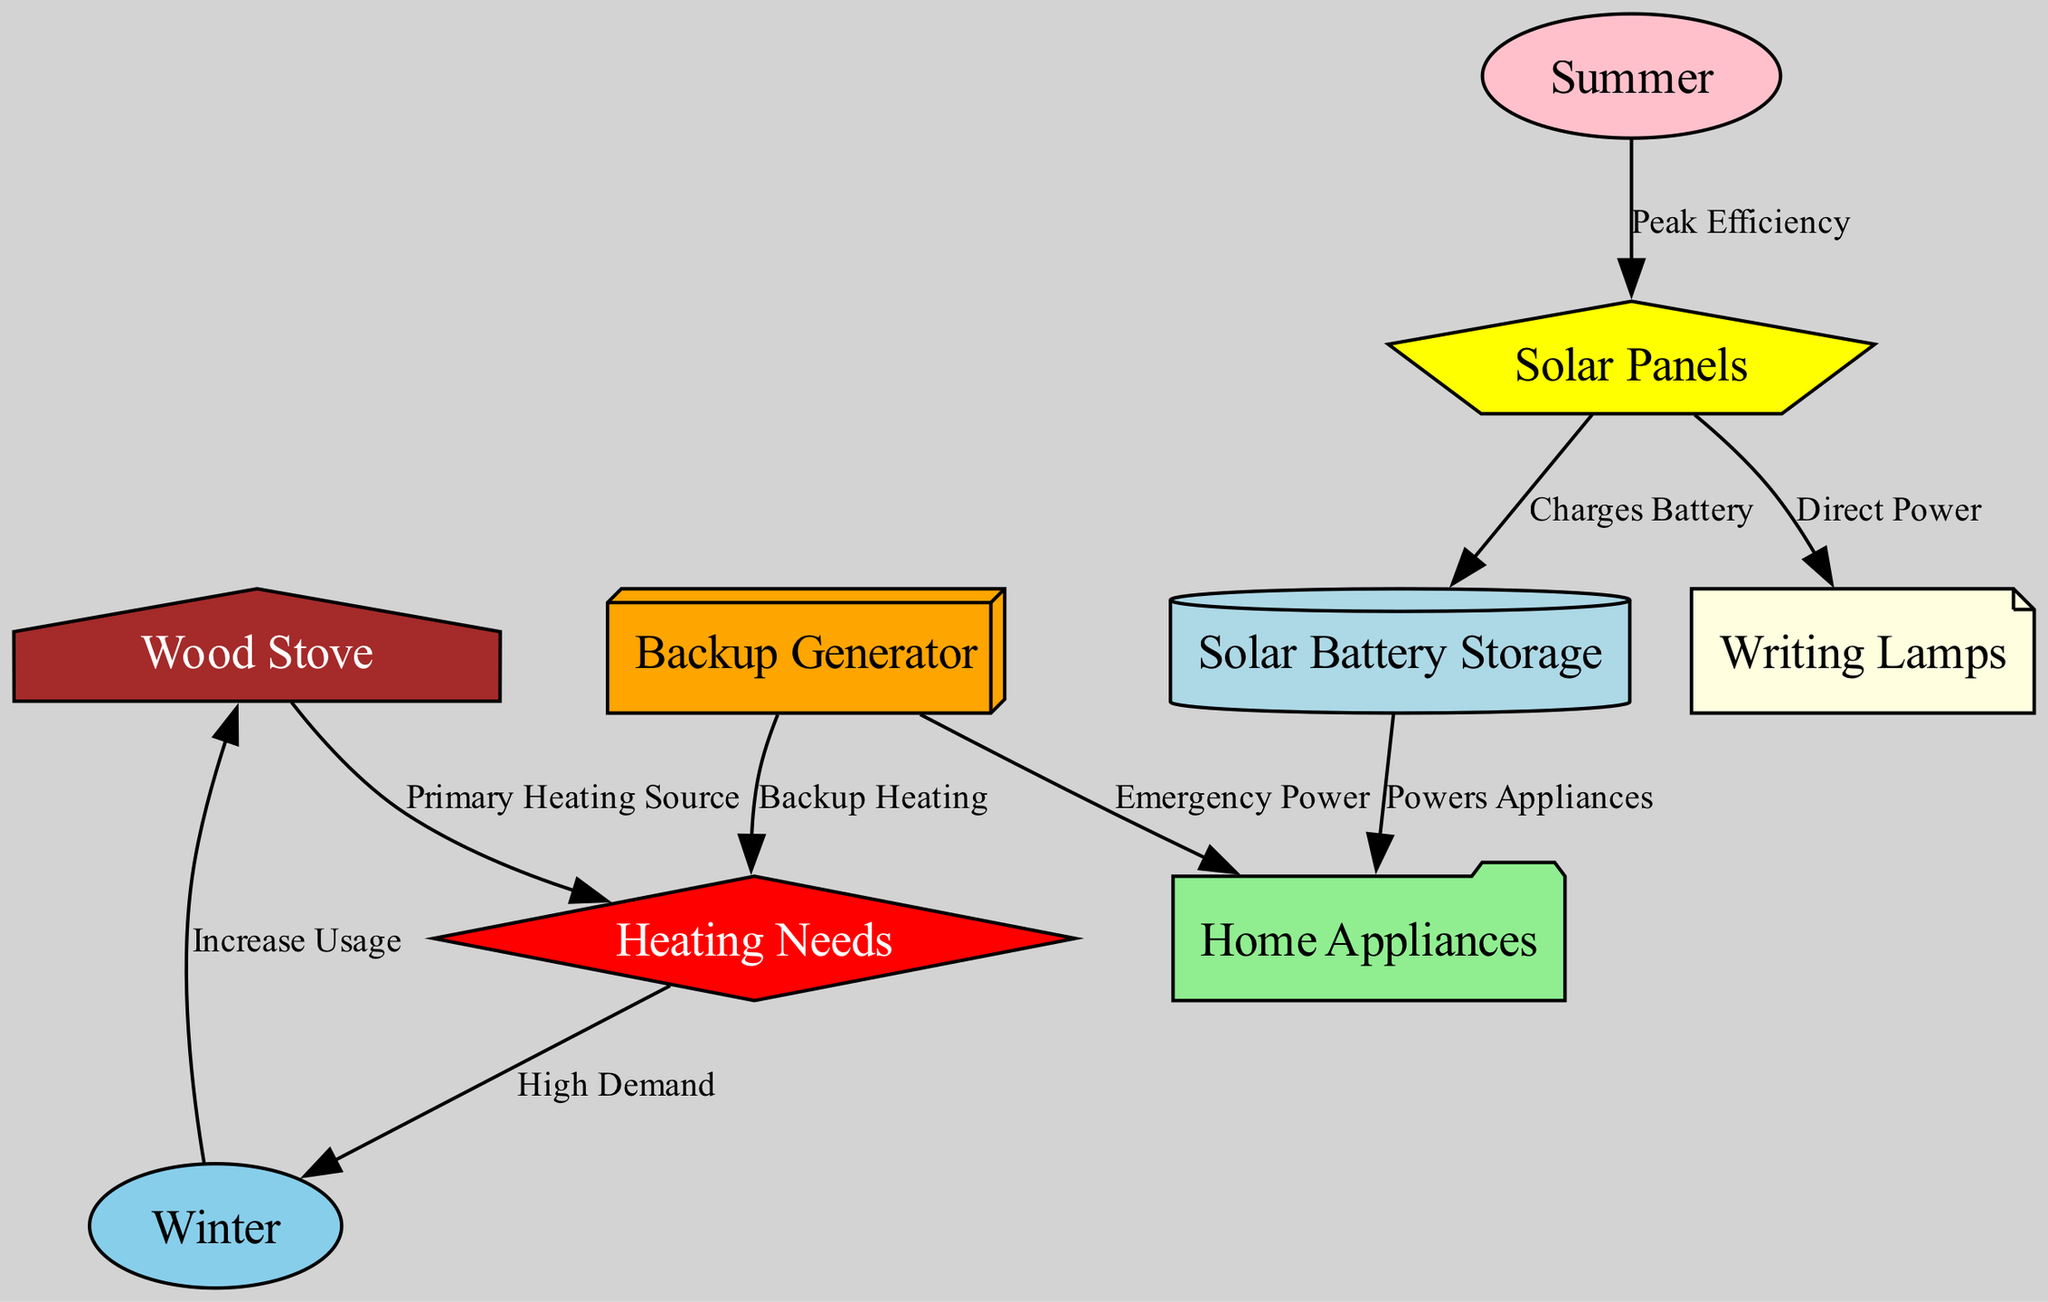What is the primary heating source for the cabin? The diagram shows that the wood stove is labeled as the "Primary Heating Source," indicating that it supplies heat mainly during the winter months.
Answer: Wood Stove Which energy source charges the solar battery? According to the diagram, the solar panels have a direct edge labeled "Charges Battery," which means they perform this function.
Answer: Solar Panels How many edges are in the diagram? By counting the connections in the diagram, we find that there are nine edges connecting various nodes, indicating the flow of energy sources and usage.
Answer: Nine What happens to wood stove usage in winter? The diagram explicitly indicates that usage increases during winter, showing a relationship between the season and the wood stove's utilization.
Answer: Increase Usage Which energy source provides emergency power? The diagram specifies that the generator is connected to the appliances with a label "Emergency Power," showing its role in providing backup energy.
Answer: Generator When do solar panels achieve peak efficiency? Based on the diagram, the summer season is indicated as the time when solar panels operate at "Peak Efficiency," reflecting optimal energy production.
Answer: Summer What is the role of the solar battery in the cabin? The solar battery is connected to the appliances in the diagram, and its label indicates it "Powers Appliances," showcasing its function in energy distribution.
Answer: Powers Appliances How is backup heating provided in the cabin? The generator is connected to the heating node with the label "Backup Heating," which reveals its role as a supplemental heating source when needed.
Answer: Backup Heating Which source powers the writing lamps directly? The diagram shows a direct connection from solar panels to writing lamps labeled "Direct Power," revealing that they receive energy directly from the solar panels.
Answer: Solar Panels 